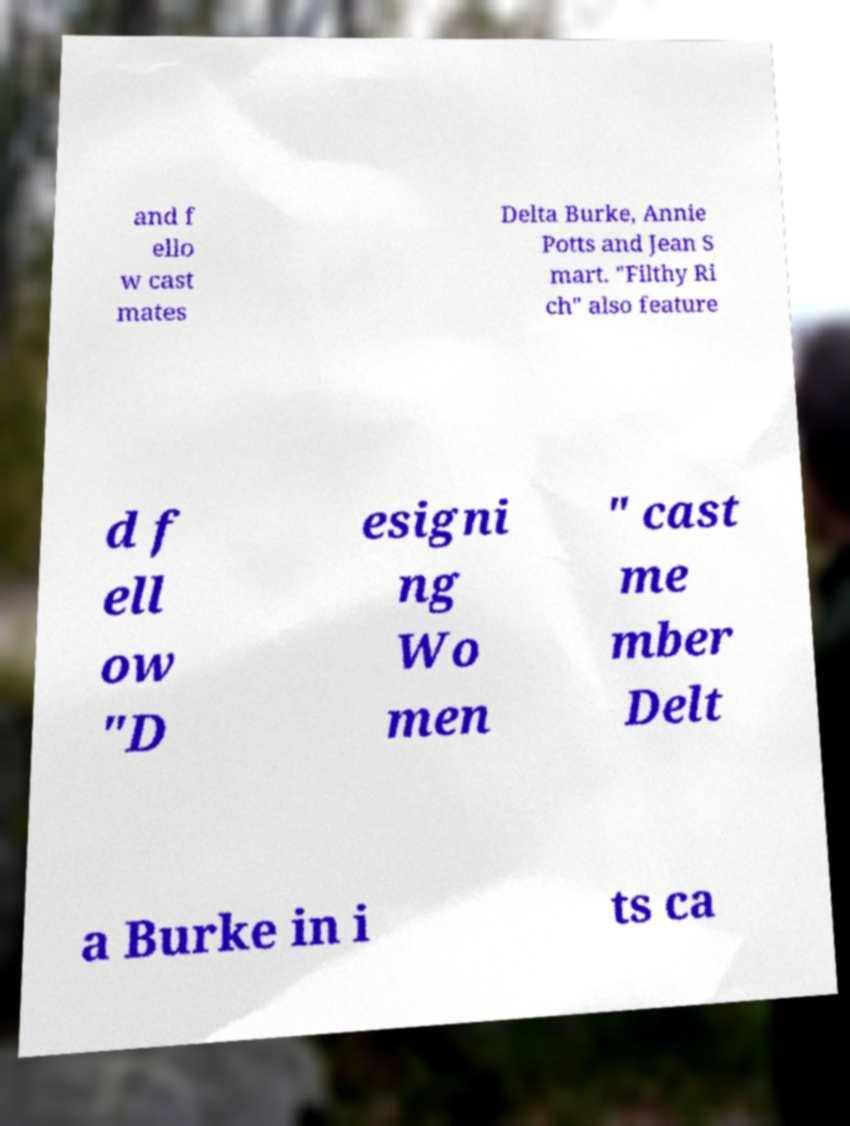Can you accurately transcribe the text from the provided image for me? and f ello w cast mates Delta Burke, Annie Potts and Jean S mart. "Filthy Ri ch" also feature d f ell ow "D esigni ng Wo men " cast me mber Delt a Burke in i ts ca 